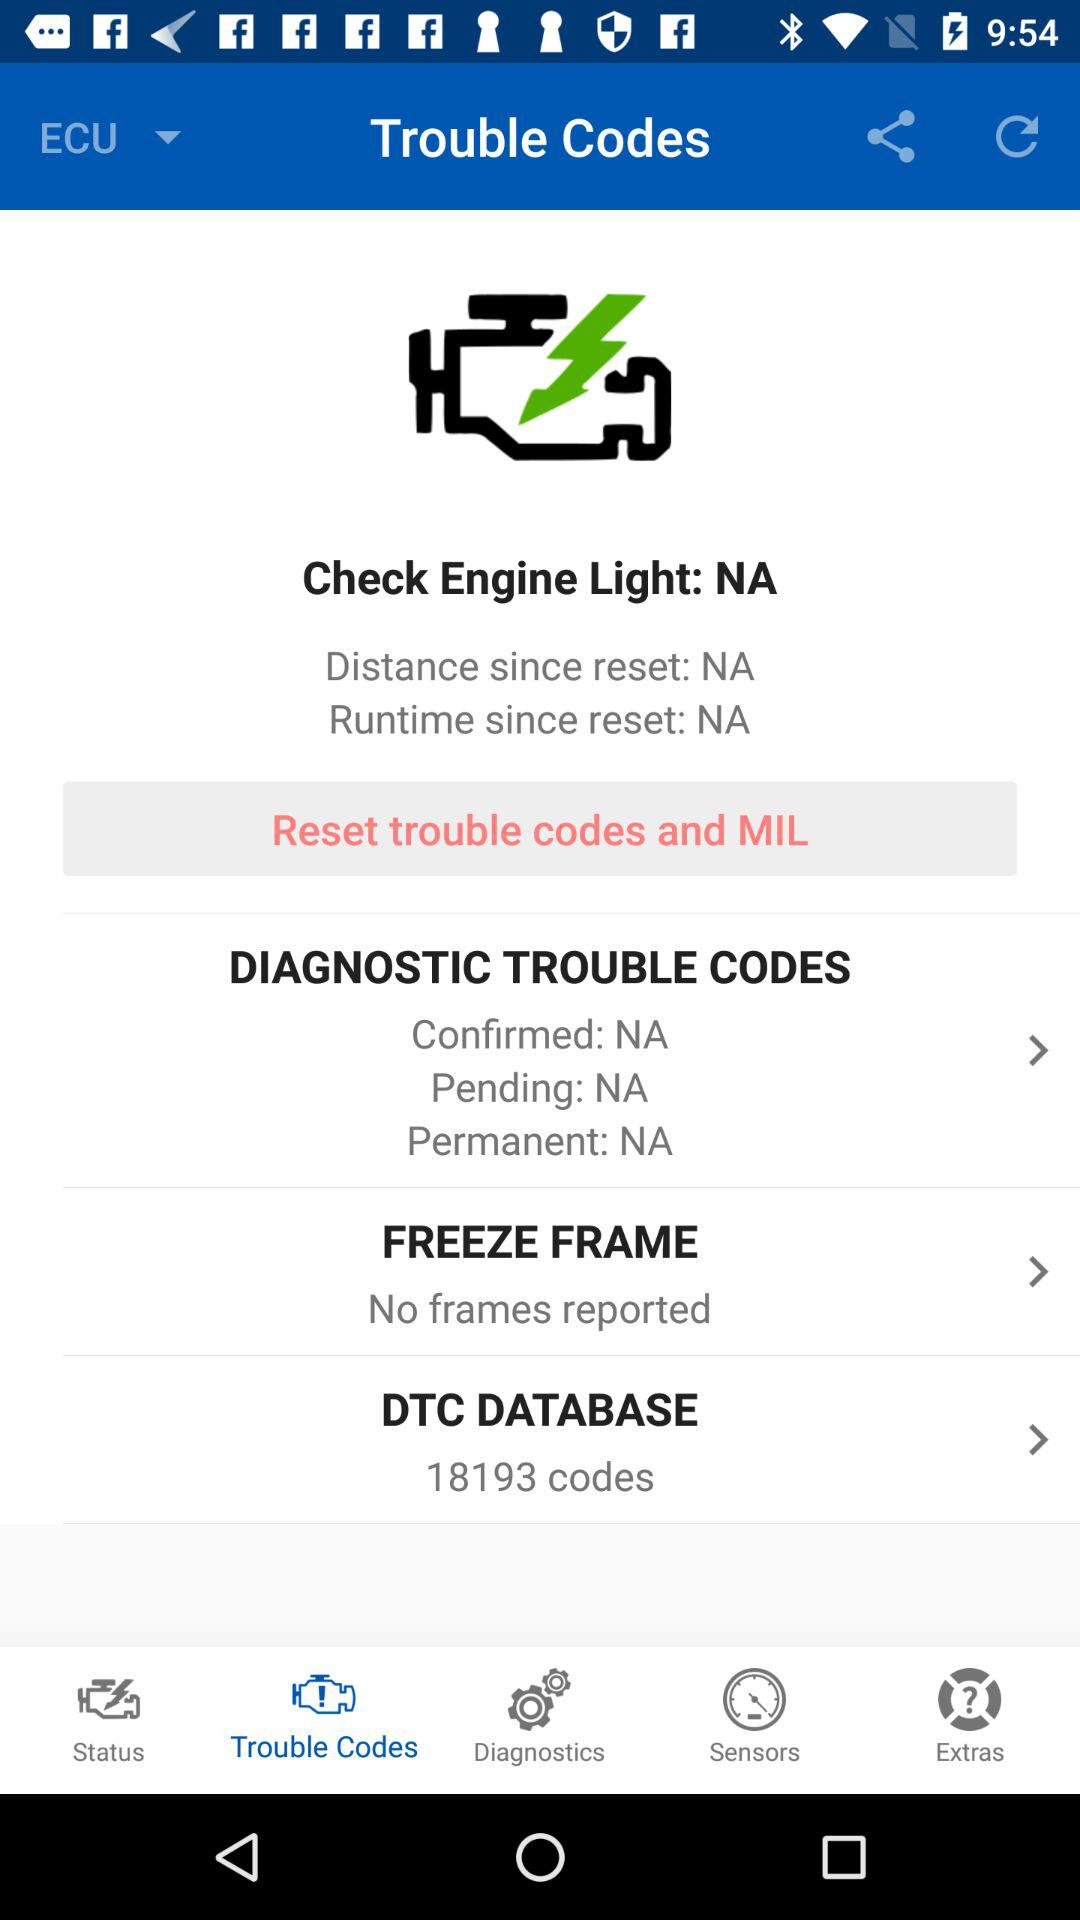What is the selected tab? The selected tab is "Trouble Codes". 